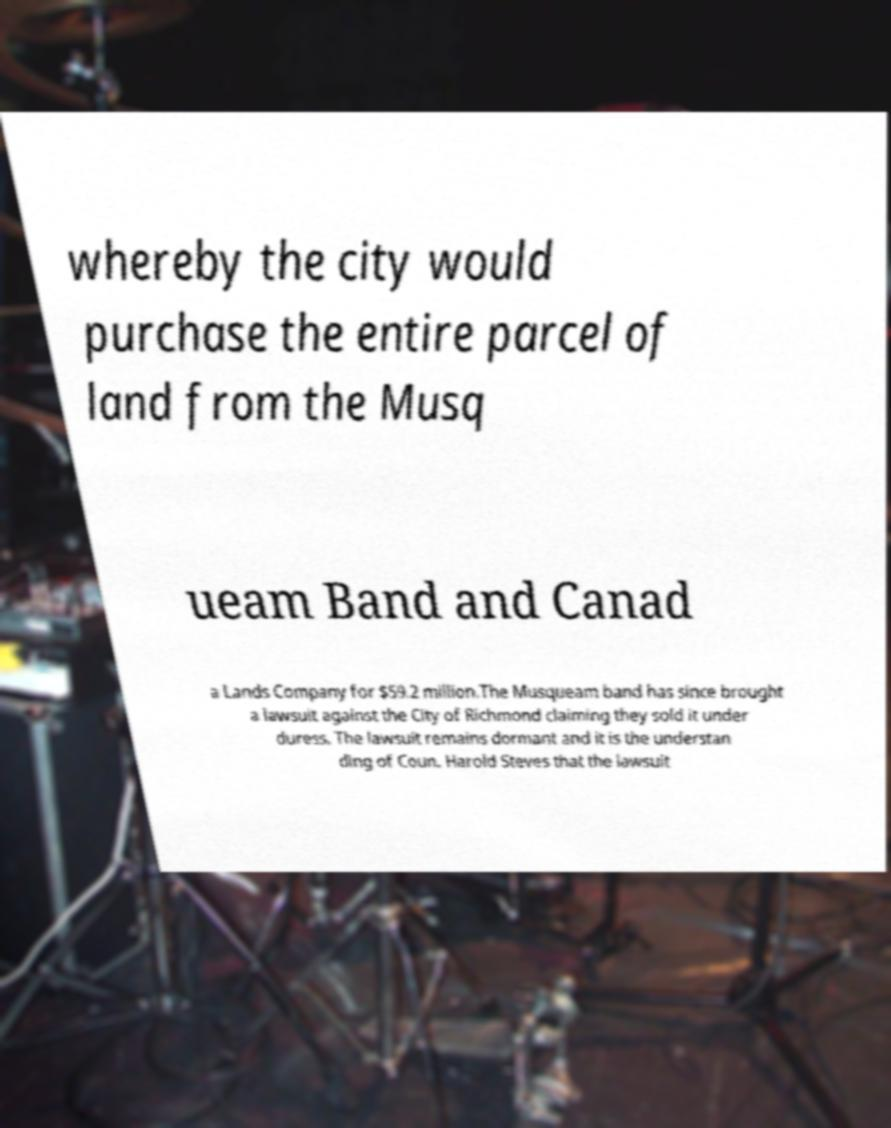Please identify and transcribe the text found in this image. whereby the city would purchase the entire parcel of land from the Musq ueam Band and Canad a Lands Company for $59.2 million.The Musqueam band has since brought a lawsuit against the City of Richmond claiming they sold it under duress. The lawsuit remains dormant and it is the understan ding of Coun. Harold Steves that the lawsuit 